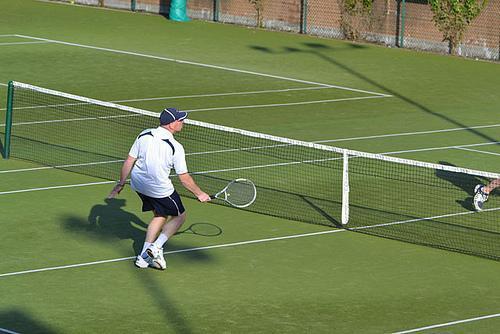How many rackets?
Give a very brief answer. 1. 